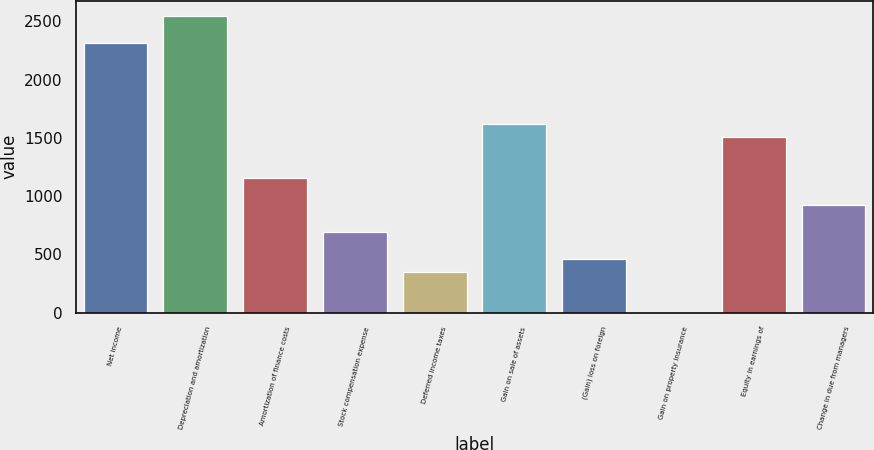Convert chart to OTSL. <chart><loc_0><loc_0><loc_500><loc_500><bar_chart><fcel>Net income<fcel>Depreciation and amortization<fcel>Amortization of finance costs<fcel>Stock compensation expense<fcel>Deferred income taxes<fcel>Gain on sale of assets<fcel>(Gain) loss on foreign<fcel>Gain on property insurance<fcel>Equity in earnings of<fcel>Change in due from managers<nl><fcel>2318<fcel>2549.6<fcel>1160<fcel>696.8<fcel>349.4<fcel>1623.2<fcel>465.2<fcel>2<fcel>1507.4<fcel>928.4<nl></chart> 